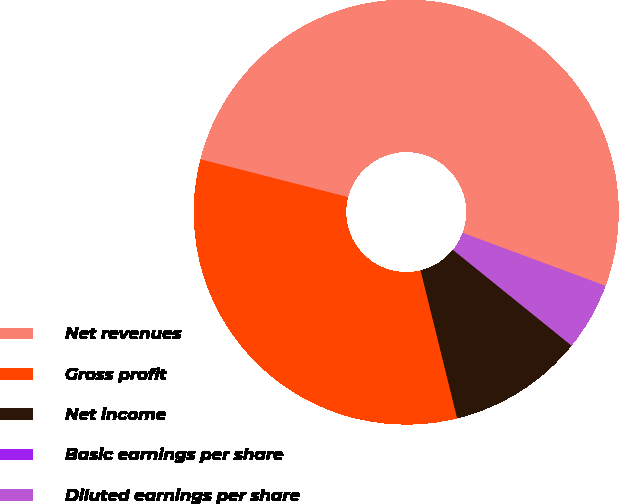<chart> <loc_0><loc_0><loc_500><loc_500><pie_chart><fcel>Net revenues<fcel>Gross profit<fcel>Net income<fcel>Basic earnings per share<fcel>Diluted earnings per share<nl><fcel>51.65%<fcel>32.85%<fcel>10.33%<fcel>0.0%<fcel>5.17%<nl></chart> 